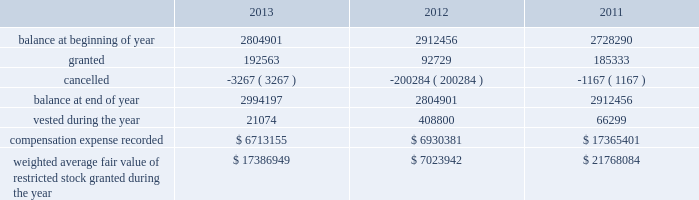During the years ended december 31 , 2013 , 2012 , and 2011 , we recognized approximately $ 6.5 million , $ 5.1 million and $ 4.7 million of compensation expense , respectively , for these options .
As of december 31 , 2013 , there was approximately $ 20.3 million of total unrecognized compensation cost related to unvested stock options , which is expected to be recognized over a weighted average period of three years .
Stock-based compensation effective january 1 , 1999 , we implemented a deferred compensation plan , or the deferred plan , covering certain of our employees , including our executives .
The shares issued under the deferred plan were granted to certain employees , including our executives and vesting will occur annually upon the completion of a service period or our meeting established financial performance criteria .
Annual vesting occurs at rates ranging from 15% ( 15 % ) to 35% ( 35 % ) once performance criteria are reached .
A summary of our restricted stock as of december 31 , 2013 , 2012 and 2011 and charges during the years then ended are presented below: .
Weighted average fair value of restricted stock granted during the year $ 17386949 $ 7023942 $ 21768084 the fair value of restricted stock that vested during the years ended december 31 , 2013 , 2012 and 2011 was $ 1.6 million , $ 22.4 million and $ 4.3 million , respectively .
As of december 31 , 2013 , there was $ 17.8 million of total unrecognized compensation cost related to unvested restricted stock , which is expected to be recognized over a weighted average period of approximately 2.7 years .
For the years ended december 31 , 2013 , 2012 and 2011 , approximately $ 4.5 million , $ 4.1 million and $ 3.4 million , respectively , was capitalized to assets associated with compensation expense related to our long-term compensation plans , restricted stock and stock options .
We granted ltip units , which include bonus , time-based and performance based awards , with a fair value of $ 27.1 million , zero and $ 8.5 million as of 2013 , 2012 and 2011 , respectively .
The grant date fair value of the ltip unit awards was calculated in accordance with asc 718 .
A third party consultant determined the fair value of the ltip units to have a discount from sl green's common stock price .
The discount was calculated by considering the inherent uncertainty that the ltip units will reach parity with other common partnership units and the illiquidity due to transfer restrictions .
As of december 31 , 2013 , there was $ 5.0 million of total unrecognized compensation expense related to the time-based and performance based awards , which is expected to be recognized over a weighted average period of approximately 1.5 years .
During the years ended december 31 , 2013 , 2012 and 2011 , we recorded compensation expense related to bonus , time-based and performance based awards of approximately $ 27.3 million , $ 12.6 million and $ 8.5 million , respectively .
2010 notional unit long-term compensation plan in december 2009 , the compensation committee of the company's board of directors approved the general terms of the sl green realty corp .
2010 notional unit long-term compensation program , or the 2010 long-term compensation plan .
The 2010 long-term compensation plan is a long-term incentive compensation plan pursuant to which award recipients could earn , in the aggregate , from approximately $ 15.0 million up to approximately $ 75.0 million of ltip units in the operating partnership based on our stock price appreciation over three years beginning on december 1 , 2009 ; provided that , if maximum performance had been achieved , approximately $ 25.0 million of awards could be earned at any time after the beginning of the second year and an additional approximately $ 25.0 million of awards could be earned at any time after the beginning of the third year .
In order to achieve maximum performance under the 2010 long-term compensation plan , our aggregate stock price appreciation during the performance period had to equal or exceed 50% ( 50 % ) .
The compensation committee determined that maximum performance had been achieved at or shortly after the beginning of each of the second and third years of the performance period and for the full performance period and , accordingly , 366815 ltip units , 385583 ltip units and 327416 ltip units were earned under the 2010 long-term compensation plan in december 2010 , 2011 and 2012 , respectively .
Substantially in accordance with the original terms of the program , 50% ( 50 % ) of these ltip units vested on december 17 , 2012 ( accelerated from the original january 1 , 2013 vesting date ) , 25% ( 25 % ) of these ltip units vested on december 11 , 2013 ( accelerated from the original january 1 , 2014 vesting date ) and the remainder is scheduled to vest on january 1 , 2015 based on .
How many restricted stocks grants were made in the three year period? 
Computations: table_sum(granted, none)
Answer: 470625.0. During the years ended december 31 , 2013 , 2012 , and 2011 , we recognized approximately $ 6.5 million , $ 5.1 million and $ 4.7 million of compensation expense , respectively , for these options .
As of december 31 , 2013 , there was approximately $ 20.3 million of total unrecognized compensation cost related to unvested stock options , which is expected to be recognized over a weighted average period of three years .
Stock-based compensation effective january 1 , 1999 , we implemented a deferred compensation plan , or the deferred plan , covering certain of our employees , including our executives .
The shares issued under the deferred plan were granted to certain employees , including our executives and vesting will occur annually upon the completion of a service period or our meeting established financial performance criteria .
Annual vesting occurs at rates ranging from 15% ( 15 % ) to 35% ( 35 % ) once performance criteria are reached .
A summary of our restricted stock as of december 31 , 2013 , 2012 and 2011 and charges during the years then ended are presented below: .
Weighted average fair value of restricted stock granted during the year $ 17386949 $ 7023942 $ 21768084 the fair value of restricted stock that vested during the years ended december 31 , 2013 , 2012 and 2011 was $ 1.6 million , $ 22.4 million and $ 4.3 million , respectively .
As of december 31 , 2013 , there was $ 17.8 million of total unrecognized compensation cost related to unvested restricted stock , which is expected to be recognized over a weighted average period of approximately 2.7 years .
For the years ended december 31 , 2013 , 2012 and 2011 , approximately $ 4.5 million , $ 4.1 million and $ 3.4 million , respectively , was capitalized to assets associated with compensation expense related to our long-term compensation plans , restricted stock and stock options .
We granted ltip units , which include bonus , time-based and performance based awards , with a fair value of $ 27.1 million , zero and $ 8.5 million as of 2013 , 2012 and 2011 , respectively .
The grant date fair value of the ltip unit awards was calculated in accordance with asc 718 .
A third party consultant determined the fair value of the ltip units to have a discount from sl green's common stock price .
The discount was calculated by considering the inherent uncertainty that the ltip units will reach parity with other common partnership units and the illiquidity due to transfer restrictions .
As of december 31 , 2013 , there was $ 5.0 million of total unrecognized compensation expense related to the time-based and performance based awards , which is expected to be recognized over a weighted average period of approximately 1.5 years .
During the years ended december 31 , 2013 , 2012 and 2011 , we recorded compensation expense related to bonus , time-based and performance based awards of approximately $ 27.3 million , $ 12.6 million and $ 8.5 million , respectively .
2010 notional unit long-term compensation plan in december 2009 , the compensation committee of the company's board of directors approved the general terms of the sl green realty corp .
2010 notional unit long-term compensation program , or the 2010 long-term compensation plan .
The 2010 long-term compensation plan is a long-term incentive compensation plan pursuant to which award recipients could earn , in the aggregate , from approximately $ 15.0 million up to approximately $ 75.0 million of ltip units in the operating partnership based on our stock price appreciation over three years beginning on december 1 , 2009 ; provided that , if maximum performance had been achieved , approximately $ 25.0 million of awards could be earned at any time after the beginning of the second year and an additional approximately $ 25.0 million of awards could be earned at any time after the beginning of the third year .
In order to achieve maximum performance under the 2010 long-term compensation plan , our aggregate stock price appreciation during the performance period had to equal or exceed 50% ( 50 % ) .
The compensation committee determined that maximum performance had been achieved at or shortly after the beginning of each of the second and third years of the performance period and for the full performance period and , accordingly , 366815 ltip units , 385583 ltip units and 327416 ltip units were earned under the 2010 long-term compensation plan in december 2010 , 2011 and 2012 , respectively .
Substantially in accordance with the original terms of the program , 50% ( 50 % ) of these ltip units vested on december 17 , 2012 ( accelerated from the original january 1 , 2013 vesting date ) , 25% ( 25 % ) of these ltip units vested on december 11 , 2013 ( accelerated from the original january 1 , 2014 vesting date ) and the remainder is scheduled to vest on january 1 , 2015 based on .
For the years ended december 31 , 2013 , 2012 and 2011 , what was the total in millions capitalized to assets associated with compensation expense related to long-term compensation plans , restricted stock and stock options?\\n? 
Computations: ((4.5 + 4.1) + 3.4)
Answer: 12.0. During the years ended december 31 , 2013 , 2012 , and 2011 , we recognized approximately $ 6.5 million , $ 5.1 million and $ 4.7 million of compensation expense , respectively , for these options .
As of december 31 , 2013 , there was approximately $ 20.3 million of total unrecognized compensation cost related to unvested stock options , which is expected to be recognized over a weighted average period of three years .
Stock-based compensation effective january 1 , 1999 , we implemented a deferred compensation plan , or the deferred plan , covering certain of our employees , including our executives .
The shares issued under the deferred plan were granted to certain employees , including our executives and vesting will occur annually upon the completion of a service period or our meeting established financial performance criteria .
Annual vesting occurs at rates ranging from 15% ( 15 % ) to 35% ( 35 % ) once performance criteria are reached .
A summary of our restricted stock as of december 31 , 2013 , 2012 and 2011 and charges during the years then ended are presented below: .
Weighted average fair value of restricted stock granted during the year $ 17386949 $ 7023942 $ 21768084 the fair value of restricted stock that vested during the years ended december 31 , 2013 , 2012 and 2011 was $ 1.6 million , $ 22.4 million and $ 4.3 million , respectively .
As of december 31 , 2013 , there was $ 17.8 million of total unrecognized compensation cost related to unvested restricted stock , which is expected to be recognized over a weighted average period of approximately 2.7 years .
For the years ended december 31 , 2013 , 2012 and 2011 , approximately $ 4.5 million , $ 4.1 million and $ 3.4 million , respectively , was capitalized to assets associated with compensation expense related to our long-term compensation plans , restricted stock and stock options .
We granted ltip units , which include bonus , time-based and performance based awards , with a fair value of $ 27.1 million , zero and $ 8.5 million as of 2013 , 2012 and 2011 , respectively .
The grant date fair value of the ltip unit awards was calculated in accordance with asc 718 .
A third party consultant determined the fair value of the ltip units to have a discount from sl green's common stock price .
The discount was calculated by considering the inherent uncertainty that the ltip units will reach parity with other common partnership units and the illiquidity due to transfer restrictions .
As of december 31 , 2013 , there was $ 5.0 million of total unrecognized compensation expense related to the time-based and performance based awards , which is expected to be recognized over a weighted average period of approximately 1.5 years .
During the years ended december 31 , 2013 , 2012 and 2011 , we recorded compensation expense related to bonus , time-based and performance based awards of approximately $ 27.3 million , $ 12.6 million and $ 8.5 million , respectively .
2010 notional unit long-term compensation plan in december 2009 , the compensation committee of the company's board of directors approved the general terms of the sl green realty corp .
2010 notional unit long-term compensation program , or the 2010 long-term compensation plan .
The 2010 long-term compensation plan is a long-term incentive compensation plan pursuant to which award recipients could earn , in the aggregate , from approximately $ 15.0 million up to approximately $ 75.0 million of ltip units in the operating partnership based on our stock price appreciation over three years beginning on december 1 , 2009 ; provided that , if maximum performance had been achieved , approximately $ 25.0 million of awards could be earned at any time after the beginning of the second year and an additional approximately $ 25.0 million of awards could be earned at any time after the beginning of the third year .
In order to achieve maximum performance under the 2010 long-term compensation plan , our aggregate stock price appreciation during the performance period had to equal or exceed 50% ( 50 % ) .
The compensation committee determined that maximum performance had been achieved at or shortly after the beginning of each of the second and third years of the performance period and for the full performance period and , accordingly , 366815 ltip units , 385583 ltip units and 327416 ltip units were earned under the 2010 long-term compensation plan in december 2010 , 2011 and 2012 , respectively .
Substantially in accordance with the original terms of the program , 50% ( 50 % ) of these ltip units vested on december 17 , 2012 ( accelerated from the original january 1 , 2013 vesting date ) , 25% ( 25 % ) of these ltip units vested on december 11 , 2013 ( accelerated from the original january 1 , 2014 vesting date ) and the remainder is scheduled to vest on january 1 , 2015 based on .
What was the increase in the shares granted from 2012 to 2013? 
Computations: (192563 - 92729)
Answer: 99834.0. 